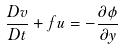<formula> <loc_0><loc_0><loc_500><loc_500>\frac { D v } { D t } + f u = - \frac { \partial \phi } { \partial y }</formula> 